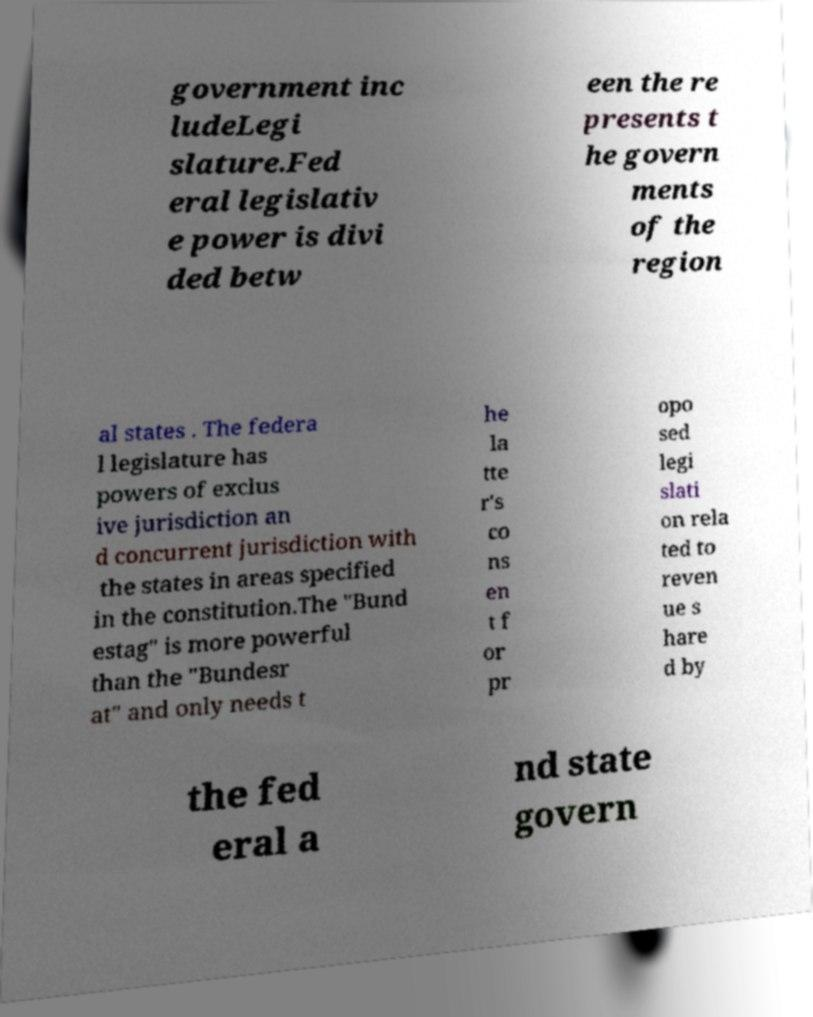Please read and relay the text visible in this image. What does it say? government inc ludeLegi slature.Fed eral legislativ e power is divi ded betw een the re presents t he govern ments of the region al states . The federa l legislature has powers of exclus ive jurisdiction an d concurrent jurisdiction with the states in areas specified in the constitution.The "Bund estag" is more powerful than the "Bundesr at" and only needs t he la tte r's co ns en t f or pr opo sed legi slati on rela ted to reven ue s hare d by the fed eral a nd state govern 